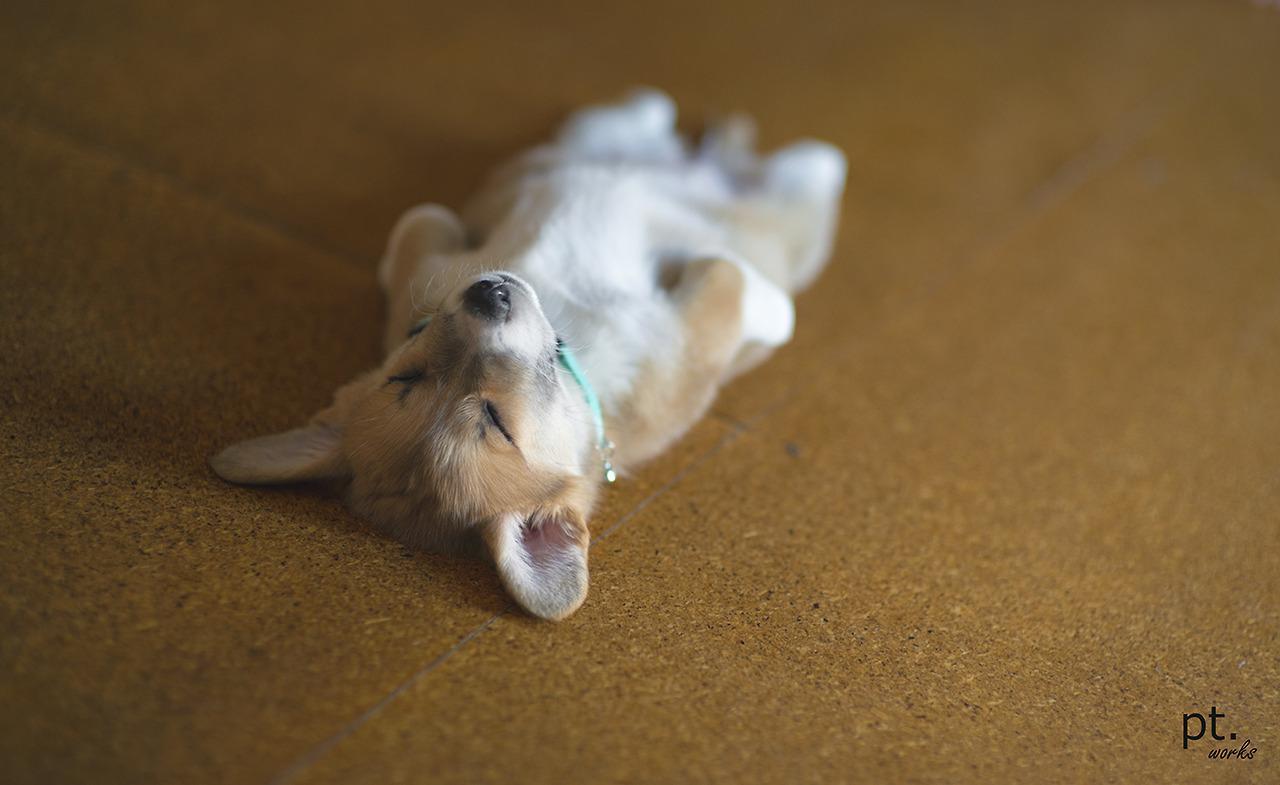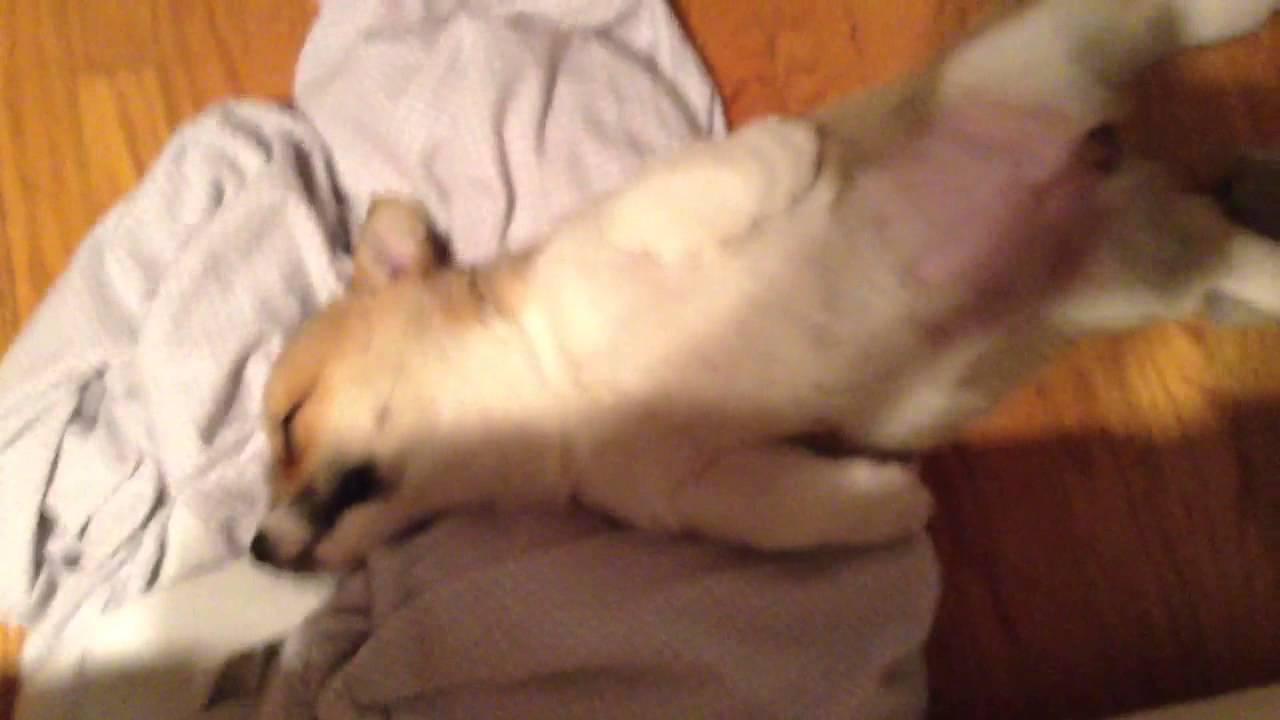The first image is the image on the left, the second image is the image on the right. For the images shown, is this caption "Both dogs are sleeping on their backs." true? Answer yes or no. Yes. The first image is the image on the left, the second image is the image on the right. Assess this claim about the two images: "Each image shows one orange-and-white corgi dog, each image shows a dog lying on its back, and one dog is wearing a bluish collar.". Correct or not? Answer yes or no. Yes. 